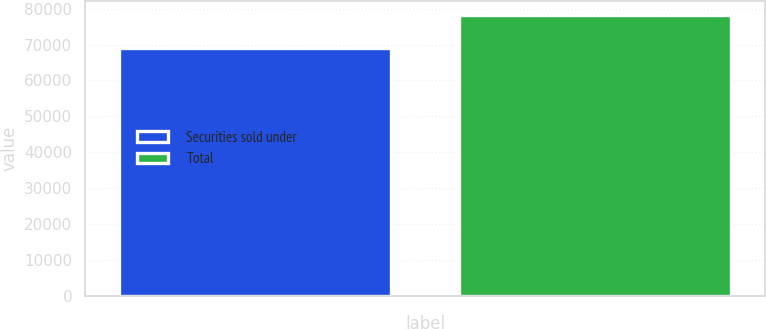<chart> <loc_0><loc_0><loc_500><loc_500><bar_chart><fcel>Securities sold under<fcel>Total<nl><fcel>68930<fcel>78156<nl></chart> 